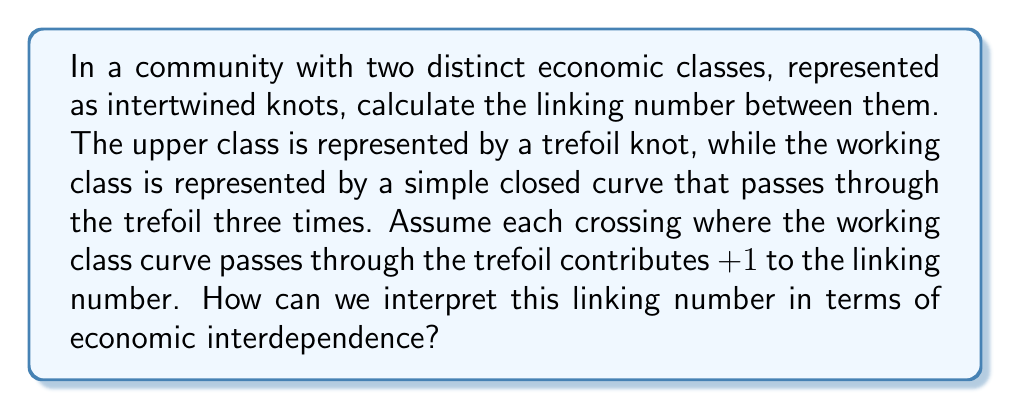Teach me how to tackle this problem. To calculate the linking number between the two economic classes represented as intertwined knots, we'll follow these steps:

1. Identify the crossings:
   The working class curve passes through the trefoil knot (upper class) three times.

2. Determine the contribution of each crossing:
   Each crossing is assumed to contribute +1 to the linking number.

3. Calculate the linking number:
   $$\text{Linking Number} = \sum_{i=1}^n \text{Contribution}_i$$
   Where $n$ is the number of crossings.
   
   In this case:
   $$\text{Linking Number} = (+1) + (+1) + (+1) = +3$$

4. Interpret the result:
   The linking number of +3 indicates a strong positive correlation between the two economic classes. In economic terms, this can be interpreted as:
   
   a) High interdependence: The two classes are closely intertwined, suggesting that the actions of one class significantly impact the other.
   
   b) Mutual influence: Changes in the upper class economy (trefoil knot) are likely to affect the working class (simple closed curve) and vice versa.
   
   c) Potential for collective action: The strong link implies that coordinated efforts between classes could lead to substantial economic changes.
   
   d) Systemic connections: The high linking number suggests that addressing economic inequalities may require considering the entire system rather than focusing on individual classes in isolation.
Answer: Linking Number: +3; Interpretation: High economic interdependence between classes 